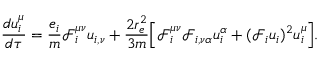<formula> <loc_0><loc_0><loc_500><loc_500>\frac { d u _ { i } ^ { \mu } } { d \tau } = \frac { e _ { i } } { m } \mathcal { F } _ { i } ^ { \mu \nu } u _ { i , \nu } + \frac { 2 r _ { e } ^ { 2 } } { 3 m } \left [ \Big . \mathcal { F } _ { i } ^ { \mu \nu } \mathcal { F } _ { i , \nu \alpha } u _ { i } ^ { \alpha } + ( \mathcal { F } _ { i } u _ { i } ) ^ { 2 } u _ { i } ^ { \mu } \Big . \right ] .</formula> 